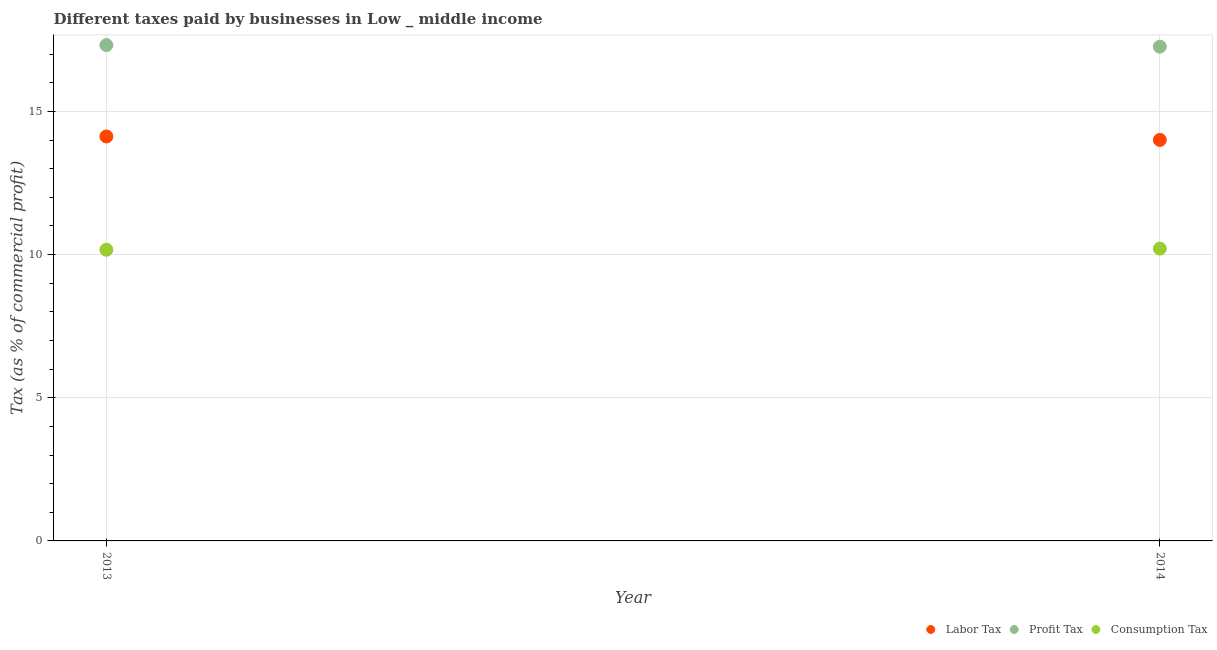How many different coloured dotlines are there?
Give a very brief answer. 3. Is the number of dotlines equal to the number of legend labels?
Your response must be concise. Yes. What is the percentage of labor tax in 2014?
Provide a succinct answer. 14. Across all years, what is the maximum percentage of consumption tax?
Keep it short and to the point. 10.21. Across all years, what is the minimum percentage of labor tax?
Provide a succinct answer. 14. In which year was the percentage of labor tax minimum?
Offer a very short reply. 2014. What is the total percentage of labor tax in the graph?
Your answer should be very brief. 28.13. What is the difference between the percentage of profit tax in 2013 and that in 2014?
Your answer should be very brief. 0.05. What is the difference between the percentage of labor tax in 2014 and the percentage of profit tax in 2013?
Offer a terse response. -3.31. What is the average percentage of profit tax per year?
Make the answer very short. 17.29. In the year 2014, what is the difference between the percentage of labor tax and percentage of profit tax?
Provide a succinct answer. -3.26. What is the ratio of the percentage of profit tax in 2013 to that in 2014?
Keep it short and to the point. 1. Is the percentage of labor tax in 2013 less than that in 2014?
Provide a short and direct response. No. How many dotlines are there?
Give a very brief answer. 3. Are the values on the major ticks of Y-axis written in scientific E-notation?
Your response must be concise. No. Does the graph contain grids?
Provide a short and direct response. Yes. What is the title of the graph?
Make the answer very short. Different taxes paid by businesses in Low _ middle income. Does "Oil" appear as one of the legend labels in the graph?
Offer a very short reply. No. What is the label or title of the X-axis?
Offer a very short reply. Year. What is the label or title of the Y-axis?
Your response must be concise. Tax (as % of commercial profit). What is the Tax (as % of commercial profit) of Labor Tax in 2013?
Provide a short and direct response. 14.12. What is the Tax (as % of commercial profit) in Profit Tax in 2013?
Keep it short and to the point. 17.31. What is the Tax (as % of commercial profit) of Consumption Tax in 2013?
Offer a terse response. 10.17. What is the Tax (as % of commercial profit) of Labor Tax in 2014?
Keep it short and to the point. 14. What is the Tax (as % of commercial profit) of Profit Tax in 2014?
Your answer should be compact. 17.26. What is the Tax (as % of commercial profit) of Consumption Tax in 2014?
Offer a terse response. 10.21. Across all years, what is the maximum Tax (as % of commercial profit) of Labor Tax?
Ensure brevity in your answer.  14.12. Across all years, what is the maximum Tax (as % of commercial profit) in Profit Tax?
Your response must be concise. 17.31. Across all years, what is the maximum Tax (as % of commercial profit) in Consumption Tax?
Your answer should be very brief. 10.21. Across all years, what is the minimum Tax (as % of commercial profit) of Labor Tax?
Your answer should be very brief. 14. Across all years, what is the minimum Tax (as % of commercial profit) in Profit Tax?
Your response must be concise. 17.26. Across all years, what is the minimum Tax (as % of commercial profit) in Consumption Tax?
Give a very brief answer. 10.17. What is the total Tax (as % of commercial profit) of Labor Tax in the graph?
Give a very brief answer. 28.13. What is the total Tax (as % of commercial profit) of Profit Tax in the graph?
Provide a succinct answer. 34.57. What is the total Tax (as % of commercial profit) in Consumption Tax in the graph?
Keep it short and to the point. 20.38. What is the difference between the Tax (as % of commercial profit) of Labor Tax in 2013 and that in 2014?
Offer a terse response. 0.12. What is the difference between the Tax (as % of commercial profit) of Profit Tax in 2013 and that in 2014?
Your answer should be very brief. 0.05. What is the difference between the Tax (as % of commercial profit) in Consumption Tax in 2013 and that in 2014?
Your response must be concise. -0.04. What is the difference between the Tax (as % of commercial profit) of Labor Tax in 2013 and the Tax (as % of commercial profit) of Profit Tax in 2014?
Give a very brief answer. -3.14. What is the difference between the Tax (as % of commercial profit) of Labor Tax in 2013 and the Tax (as % of commercial profit) of Consumption Tax in 2014?
Make the answer very short. 3.92. What is the difference between the Tax (as % of commercial profit) of Profit Tax in 2013 and the Tax (as % of commercial profit) of Consumption Tax in 2014?
Offer a terse response. 7.11. What is the average Tax (as % of commercial profit) of Labor Tax per year?
Your answer should be compact. 14.06. What is the average Tax (as % of commercial profit) in Profit Tax per year?
Give a very brief answer. 17.29. What is the average Tax (as % of commercial profit) of Consumption Tax per year?
Keep it short and to the point. 10.19. In the year 2013, what is the difference between the Tax (as % of commercial profit) in Labor Tax and Tax (as % of commercial profit) in Profit Tax?
Ensure brevity in your answer.  -3.19. In the year 2013, what is the difference between the Tax (as % of commercial profit) in Labor Tax and Tax (as % of commercial profit) in Consumption Tax?
Give a very brief answer. 3.96. In the year 2013, what is the difference between the Tax (as % of commercial profit) of Profit Tax and Tax (as % of commercial profit) of Consumption Tax?
Ensure brevity in your answer.  7.15. In the year 2014, what is the difference between the Tax (as % of commercial profit) of Labor Tax and Tax (as % of commercial profit) of Profit Tax?
Provide a short and direct response. -3.26. In the year 2014, what is the difference between the Tax (as % of commercial profit) in Labor Tax and Tax (as % of commercial profit) in Consumption Tax?
Make the answer very short. 3.8. In the year 2014, what is the difference between the Tax (as % of commercial profit) of Profit Tax and Tax (as % of commercial profit) of Consumption Tax?
Your answer should be compact. 7.05. What is the ratio of the Tax (as % of commercial profit) of Labor Tax in 2013 to that in 2014?
Offer a terse response. 1.01. What is the difference between the highest and the second highest Tax (as % of commercial profit) in Labor Tax?
Keep it short and to the point. 0.12. What is the difference between the highest and the second highest Tax (as % of commercial profit) in Profit Tax?
Your answer should be very brief. 0.05. What is the difference between the highest and the second highest Tax (as % of commercial profit) of Consumption Tax?
Your response must be concise. 0.04. What is the difference between the highest and the lowest Tax (as % of commercial profit) in Labor Tax?
Keep it short and to the point. 0.12. What is the difference between the highest and the lowest Tax (as % of commercial profit) in Profit Tax?
Give a very brief answer. 0.05. What is the difference between the highest and the lowest Tax (as % of commercial profit) of Consumption Tax?
Your response must be concise. 0.04. 